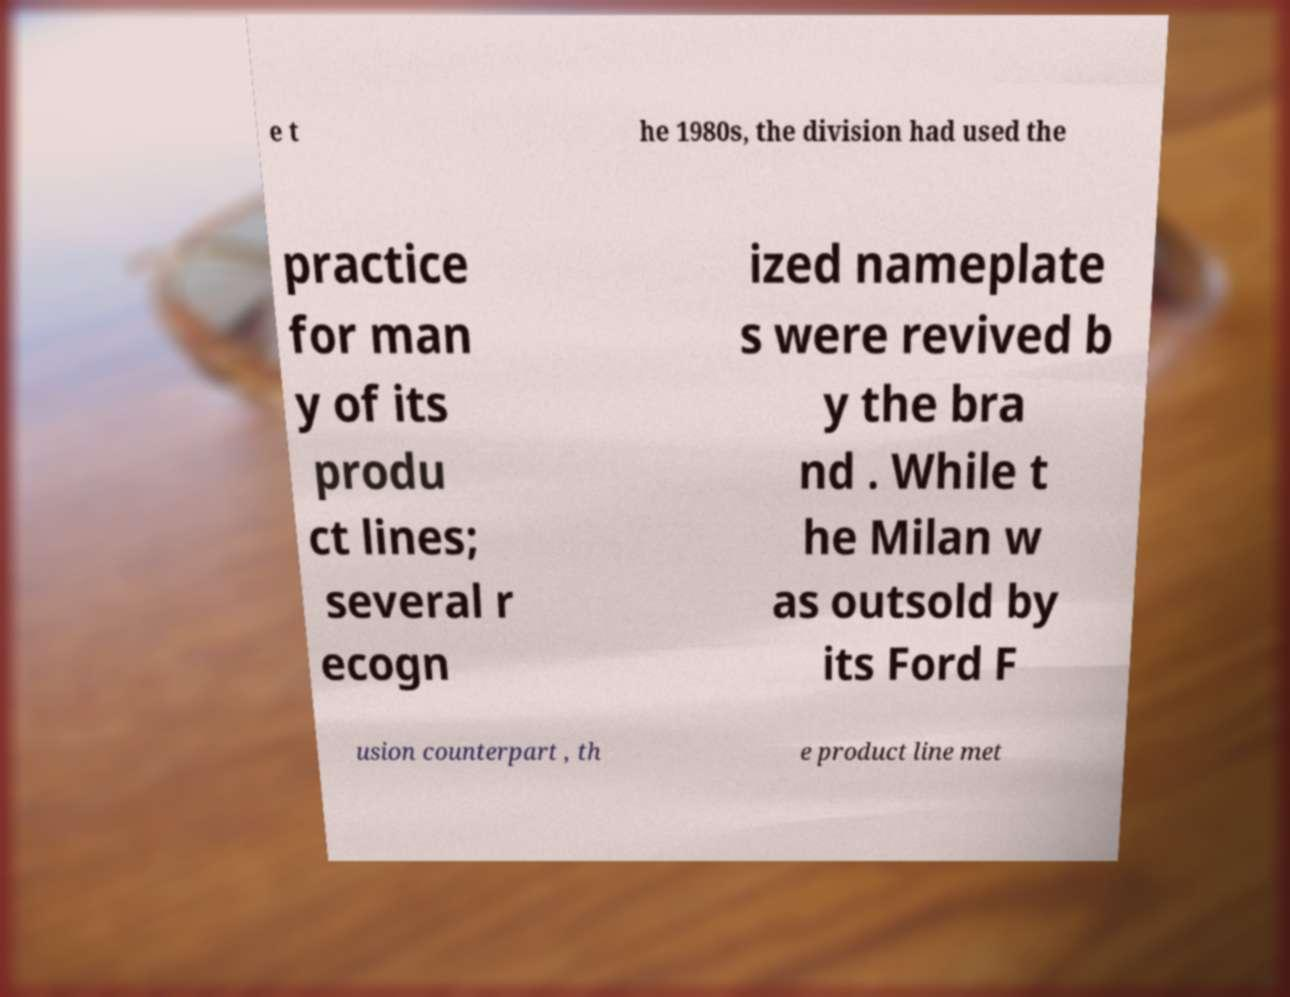Please read and relay the text visible in this image. What does it say? e t he 1980s, the division had used the practice for man y of its produ ct lines; several r ecogn ized nameplate s were revived b y the bra nd . While t he Milan w as outsold by its Ford F usion counterpart , th e product line met 